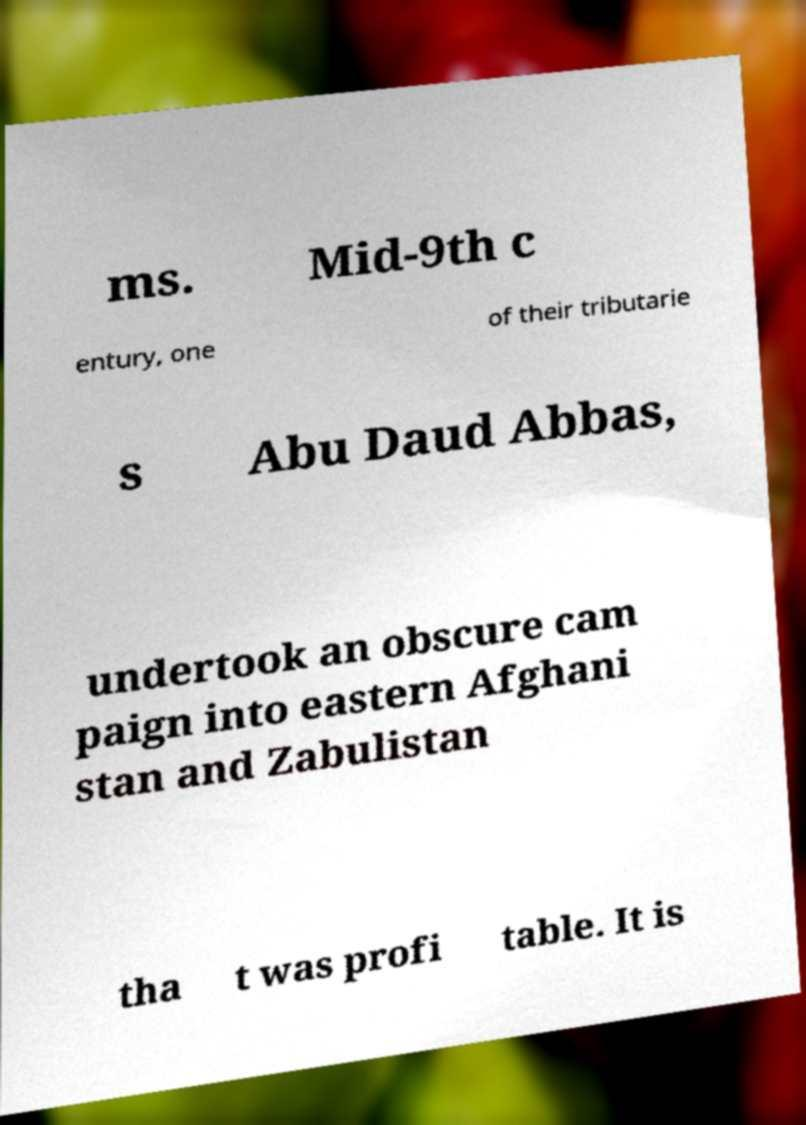What messages or text are displayed in this image? I need them in a readable, typed format. ms. Mid-9th c entury, one of their tributarie s Abu Daud Abbas, undertook an obscure cam paign into eastern Afghani stan and Zabulistan tha t was profi table. It is 